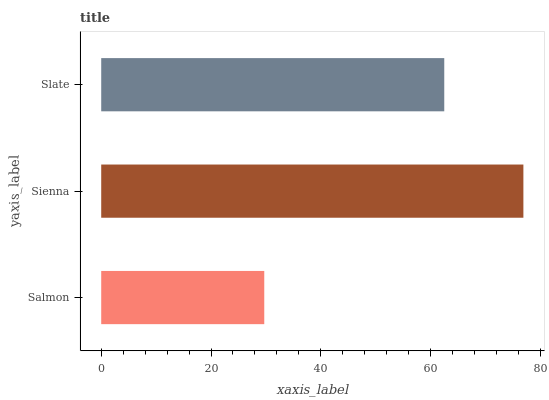Is Salmon the minimum?
Answer yes or no. Yes. Is Sienna the maximum?
Answer yes or no. Yes. Is Slate the minimum?
Answer yes or no. No. Is Slate the maximum?
Answer yes or no. No. Is Sienna greater than Slate?
Answer yes or no. Yes. Is Slate less than Sienna?
Answer yes or no. Yes. Is Slate greater than Sienna?
Answer yes or no. No. Is Sienna less than Slate?
Answer yes or no. No. Is Slate the high median?
Answer yes or no. Yes. Is Slate the low median?
Answer yes or no. Yes. Is Sienna the high median?
Answer yes or no. No. Is Salmon the low median?
Answer yes or no. No. 